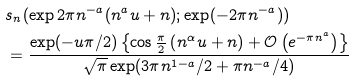<formula> <loc_0><loc_0><loc_500><loc_500>& s _ { n } ( \exp 2 \pi n ^ { - a } ( n ^ { a } u + n ) ; \exp ( - 2 \pi n ^ { - a } ) ) \\ & = \frac { \exp ( - u \pi / 2 ) \left \{ \cos \frac { \pi } { 2 } \left ( n ^ { \alpha } u + n \right ) + \mathcal { O } \left ( e ^ { - \pi n ^ { a } } \right ) \right \} } { \sqrt { \pi } \exp ( 3 \pi n ^ { 1 - a } / 2 + \pi n ^ { - a } / 4 ) }</formula> 